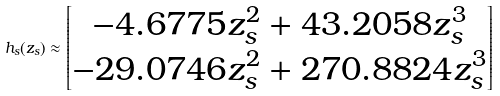Convert formula to latex. <formula><loc_0><loc_0><loc_500><loc_500>h _ { s } ( z _ { s } ) \approx \begin{bmatrix} - 4 . 6 7 7 5 z _ { s } ^ { 2 } + 4 3 . 2 0 5 8 z _ { s } ^ { 3 } \\ - 2 9 . 0 7 4 6 z _ { s } ^ { 2 } + 2 7 0 . 8 8 2 4 z _ { s } ^ { 3 } \end{bmatrix}</formula> 